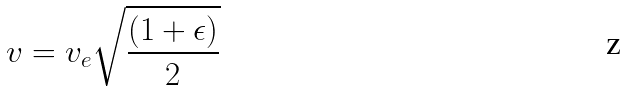<formula> <loc_0><loc_0><loc_500><loc_500>v = v _ { e } \sqrt { \frac { ( 1 + \epsilon ) } { 2 } }</formula> 